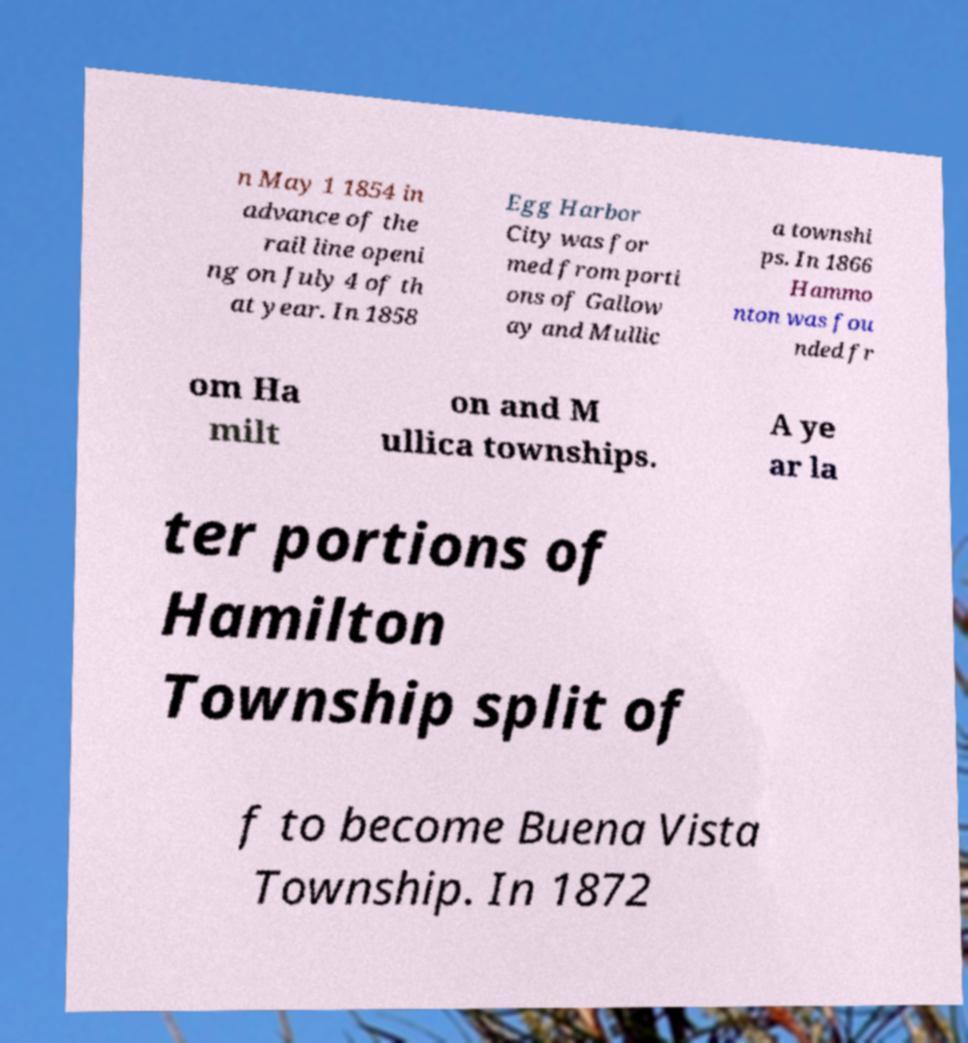For documentation purposes, I need the text within this image transcribed. Could you provide that? n May 1 1854 in advance of the rail line openi ng on July 4 of th at year. In 1858 Egg Harbor City was for med from porti ons of Gallow ay and Mullic a townshi ps. In 1866 Hammo nton was fou nded fr om Ha milt on and M ullica townships. A ye ar la ter portions of Hamilton Township split of f to become Buena Vista Township. In 1872 